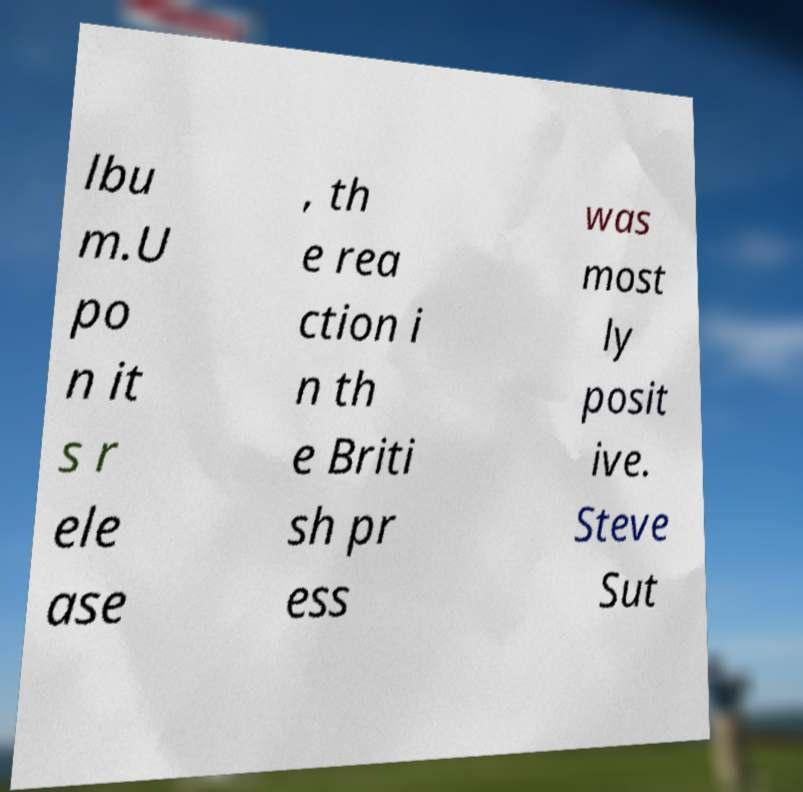Please read and relay the text visible in this image. What does it say? lbu m.U po n it s r ele ase , th e rea ction i n th e Briti sh pr ess was most ly posit ive. Steve Sut 